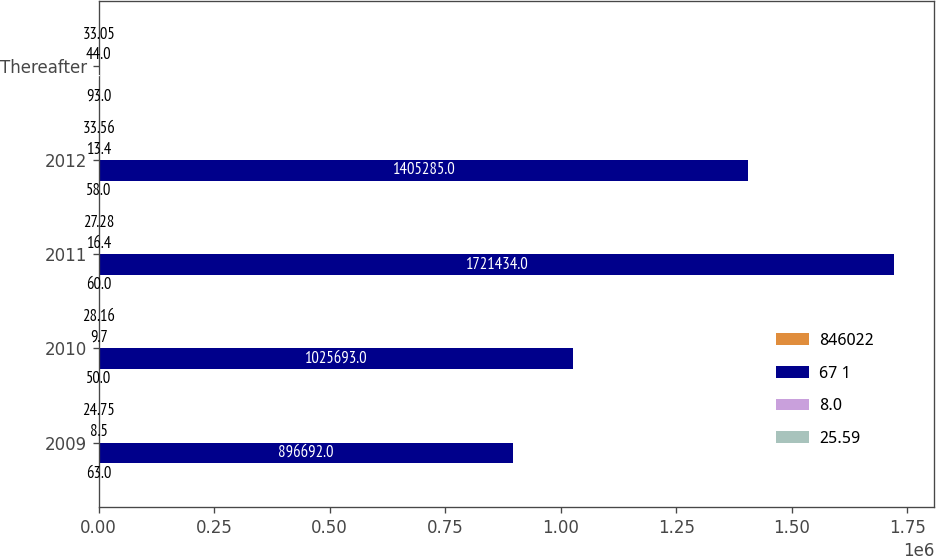Convert chart to OTSL. <chart><loc_0><loc_0><loc_500><loc_500><stacked_bar_chart><ecel><fcel>2009<fcel>2010<fcel>2011<fcel>2012<fcel>Thereafter<nl><fcel>846022<fcel>63<fcel>50<fcel>60<fcel>58<fcel>93<nl><fcel>67 1<fcel>896692<fcel>1.02569e+06<fcel>1.72143e+06<fcel>1.40528e+06<fcel>44<nl><fcel>8.0<fcel>8.5<fcel>9.7<fcel>16.4<fcel>13.4<fcel>44<nl><fcel>25.59<fcel>24.75<fcel>28.16<fcel>27.28<fcel>33.56<fcel>33.05<nl></chart> 